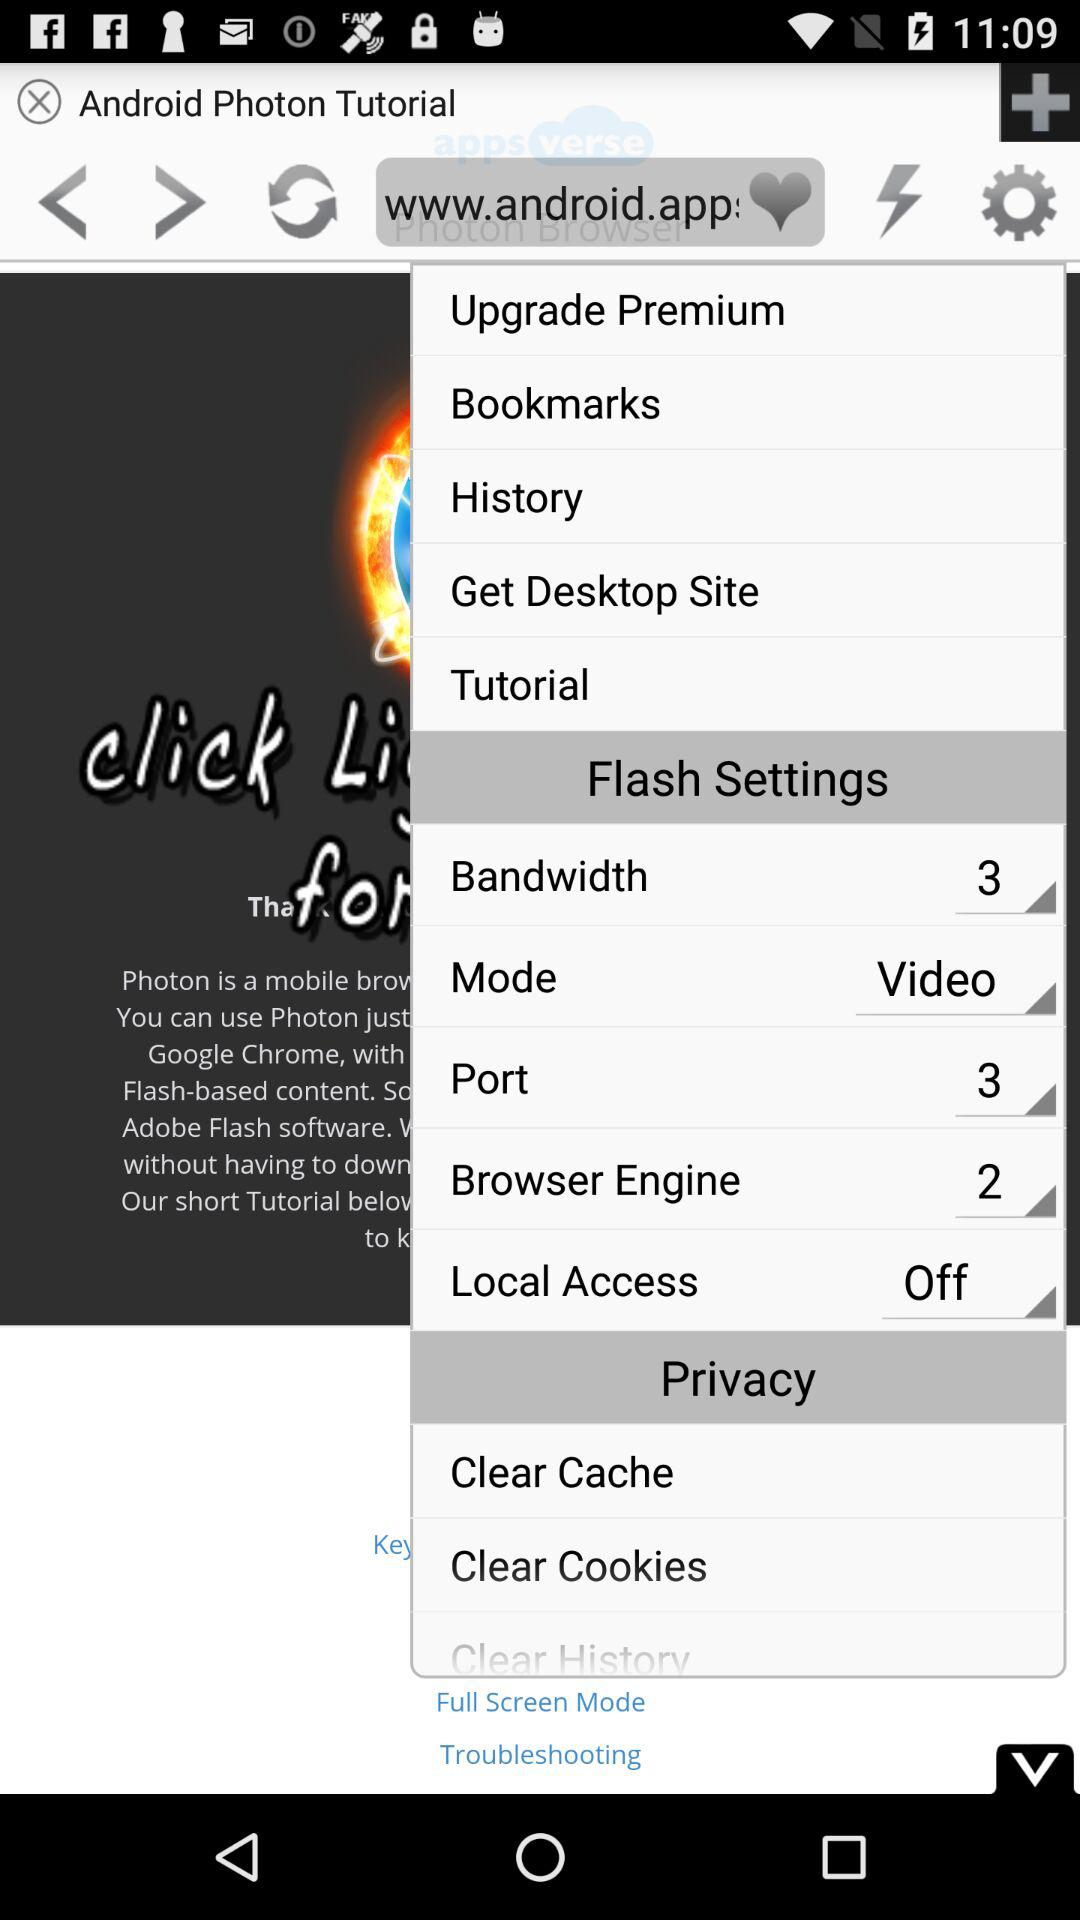How many numbers are there in the browser engine? The number is 2. 